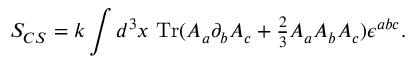Convert formula to latex. <formula><loc_0><loc_0><loc_500><loc_500>S _ { C S } = k \int d ^ { 3 } x \ T r ( A _ { a } \partial _ { b } A _ { c } + { \frac { 2 } { 3 } } A _ { a } A _ { b } A _ { c } ) \epsilon ^ { a b c } .</formula> 